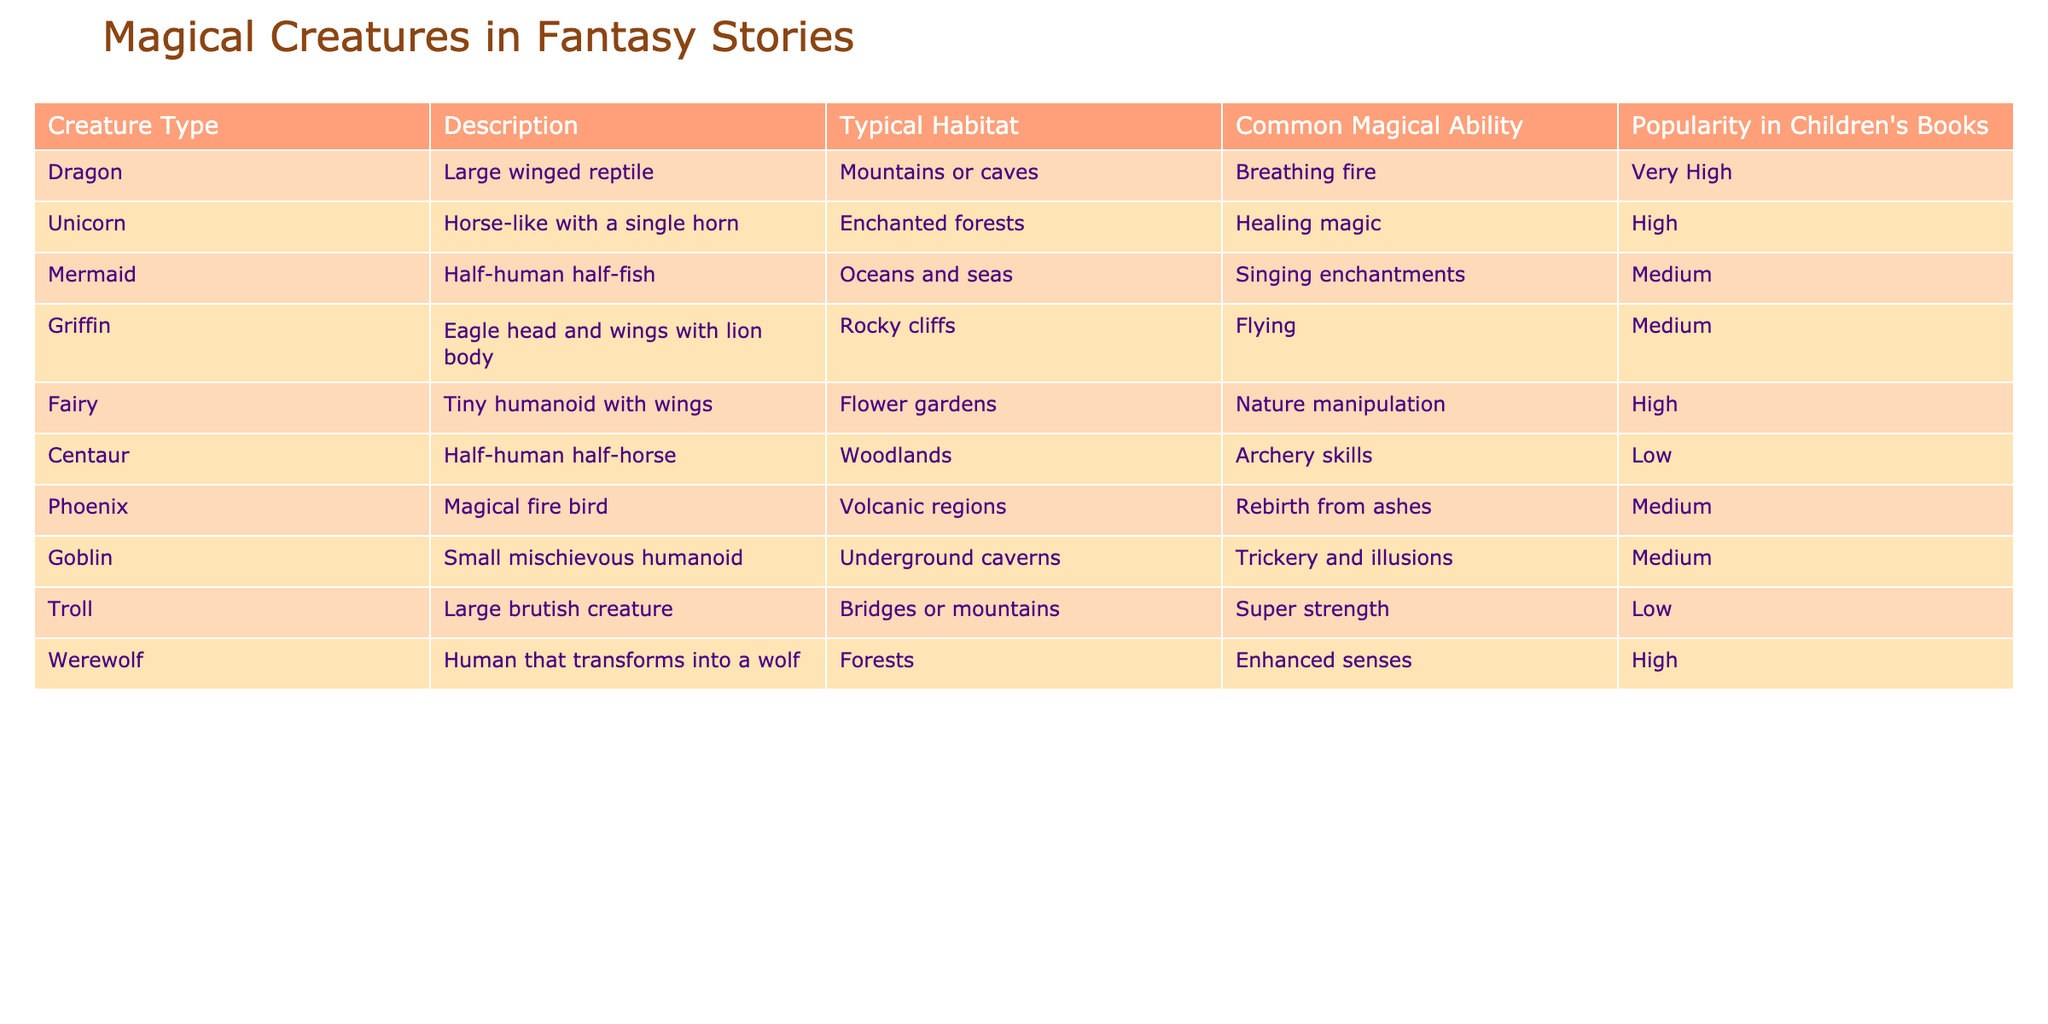What magical creature has the highest popularity in children's books? The table shows different magical creatures with a corresponding popularity rating. By examining the "Popularity in Children's Books" column, I see that both Dragon and Werewolf are labeled as "Very High," but Dragon is mentioned first. Thus, Dragon has the highest popularity.
Answer: Dragon Which creature is known for its singing enchantments? In the table, I find that the Mermaid is described as having "Singing enchantments" as its common magical ability.
Answer: Mermaid How many creatures have "Medium" popularity? By counting the entries labeled as "Medium" in the "Popularity in Children's Books" column, we find that there are four creatures: Mermaid, Griffin, Phoenix, and Goblin.
Answer: 4 Are there any creatures that can breathe fire? Looking at the "Common Magical Ability" column, I find that the Dragon is the only creature mentioned that can breathe fire.
Answer: Yes What is the typical habitat of the Unicorn? The table's "Typical Habitat" column shows that the Unicorn typically resides in "Enchanted forests."
Answer: Enchanted forests Which magical creature has the unique ability of rebirth from ashes? According to the table, the Phoenix is the magical creature noted for its ability of rebirth from ashes.
Answer: Phoenix What is the difference in popularity between the Fairy and Centaur? The Fairy has a popularity rating of "High" while the Centaur is rated "Low." This represents a difference of two popular levels. Hence, it is High – Low = 2 levels difference.
Answer: 2 levels Is there a creature that has both "Super strength" and "High" popularity? The table lists Troll with super strength but has a popularity rating of "Low." No creature embodies both characteristics, so the answer is no.
Answer: No Which creature has the lowest popularity, and what is its common magical ability? The Centaur and Troll are the lowest on the popularity scale, rated "Low." Looking at the common magical abilities, the Centaur has "Archery skills," while the Troll has "Super strength." Hence, the answer depends on the focus creature, but mentioning either is correct.
Answer: Centaur - Archery skills (or Troll - Super strength) Count the total number of creature types that have "High" or "Very High" popularity. Checking the popularity levels, we find that Dragon, Unicorn, Fairy, and Werewolf are rated as "Very High" and "High." This gives us 6 creatures in total: 1 (Dragon) + 1 (Unicorn) + 1 (Fairy) + 1 (Werewolf) = 4.
Answer: 4 